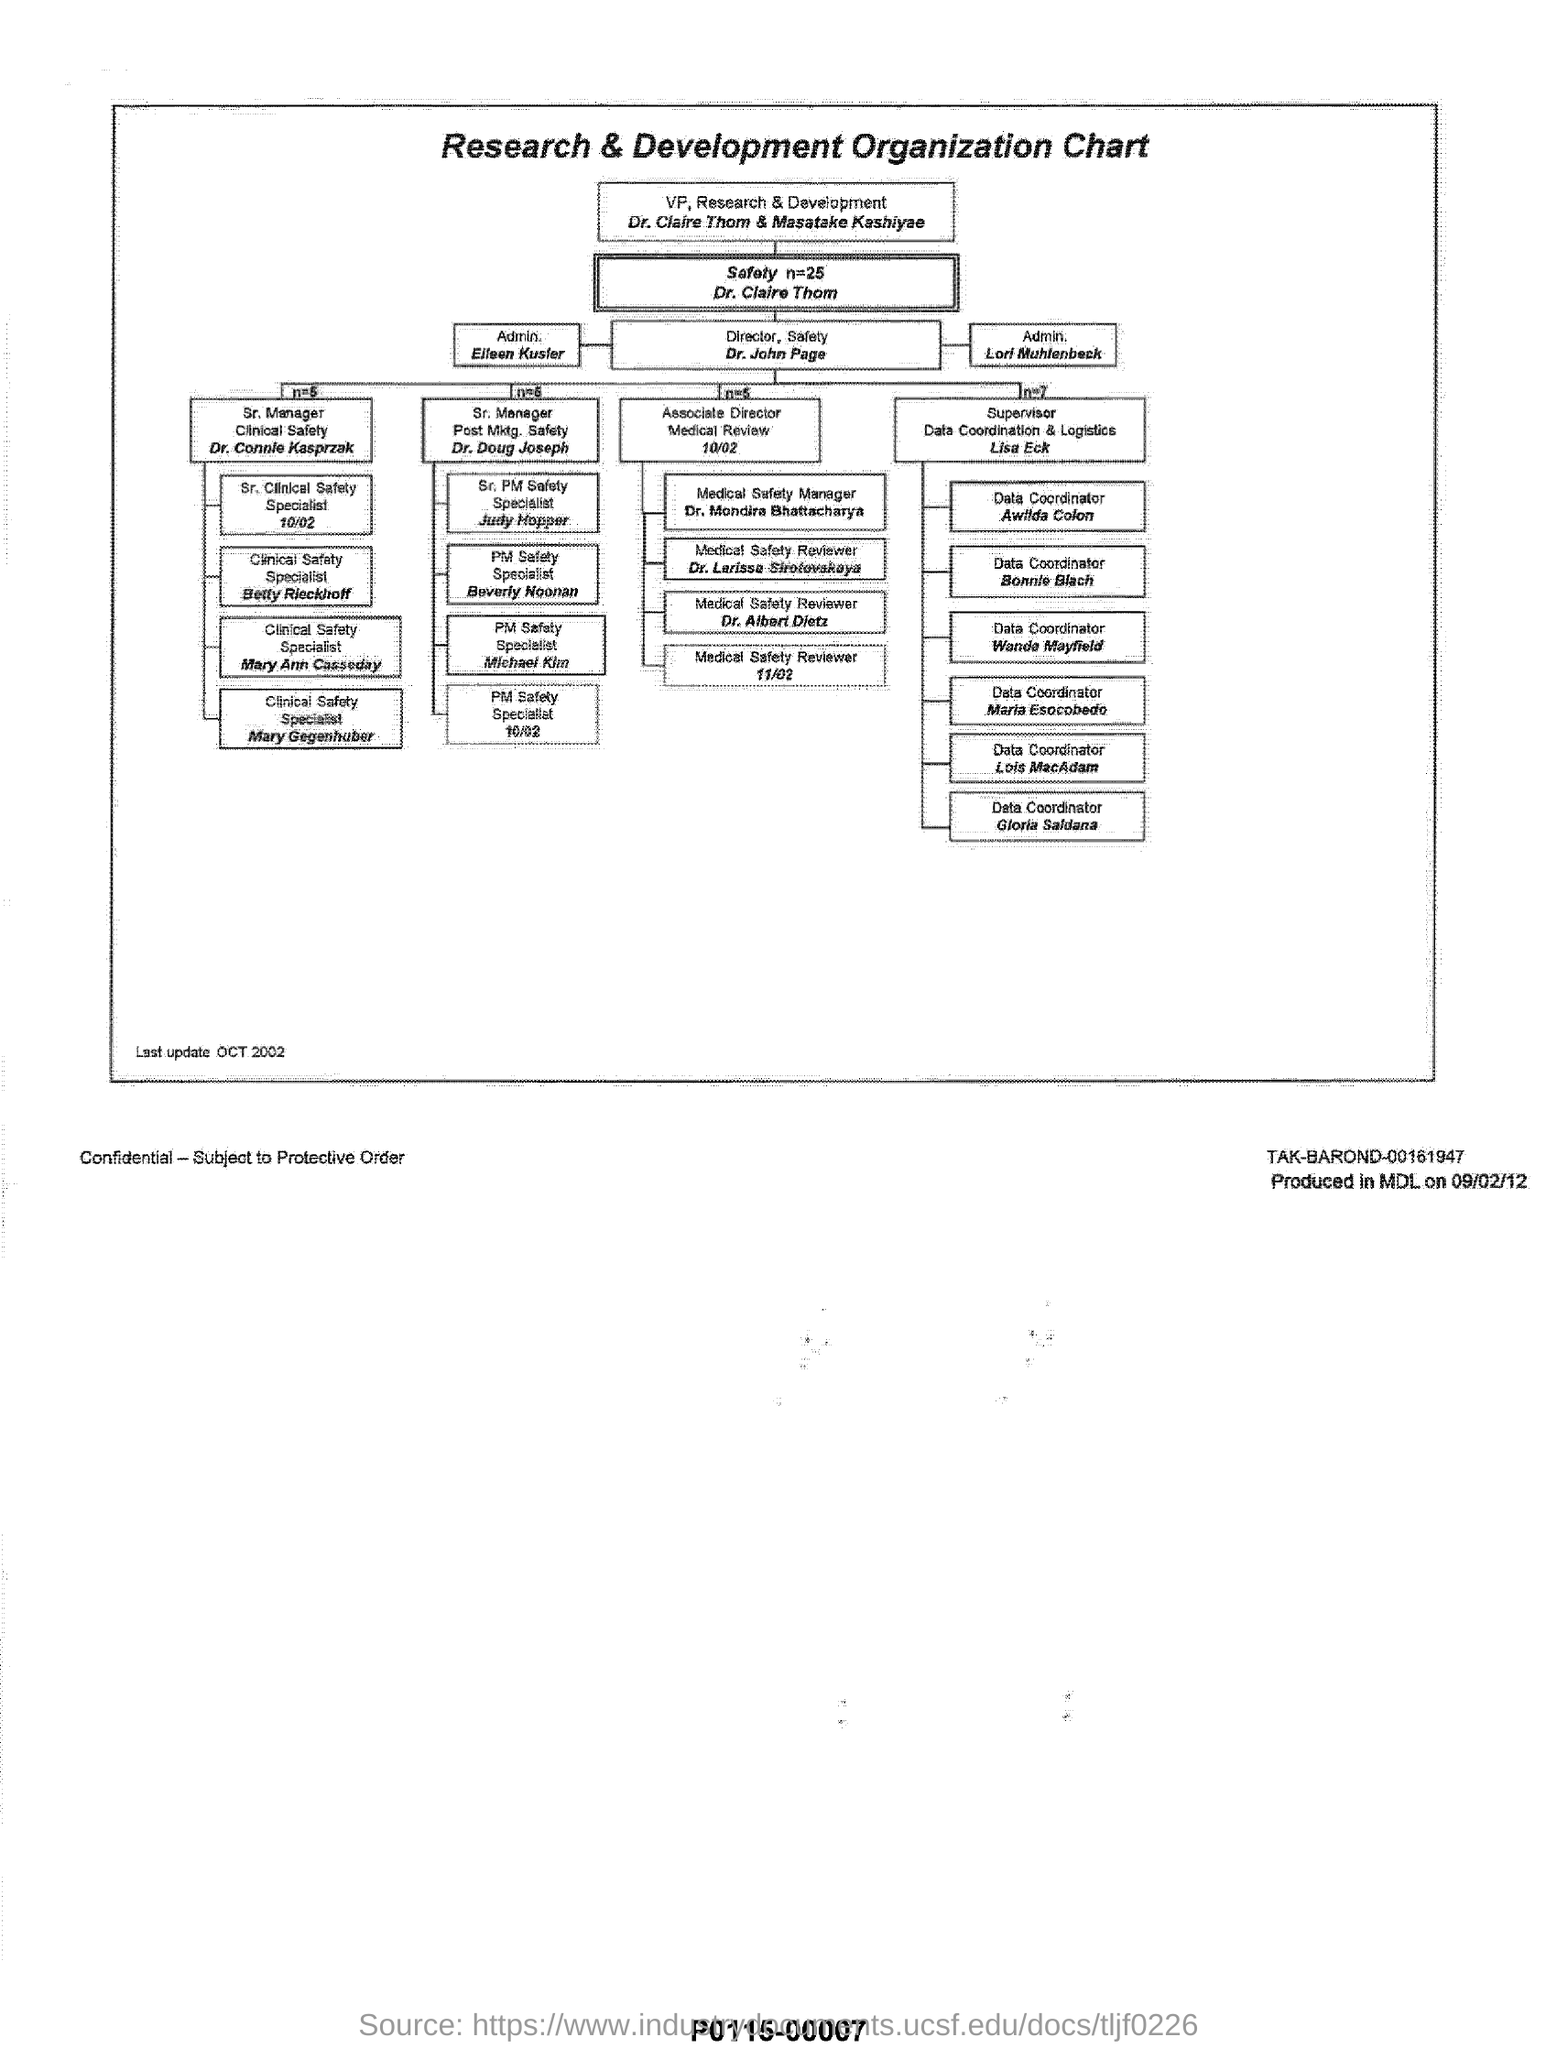What is the heading
Offer a very short reply. Research & Development Organization Chart. Who is vp, research & development
Your answer should be very brief. Dr. Claire Thom & Masatake Kashiyae. Who is director,safety
Offer a terse response. Dr. John Page. 